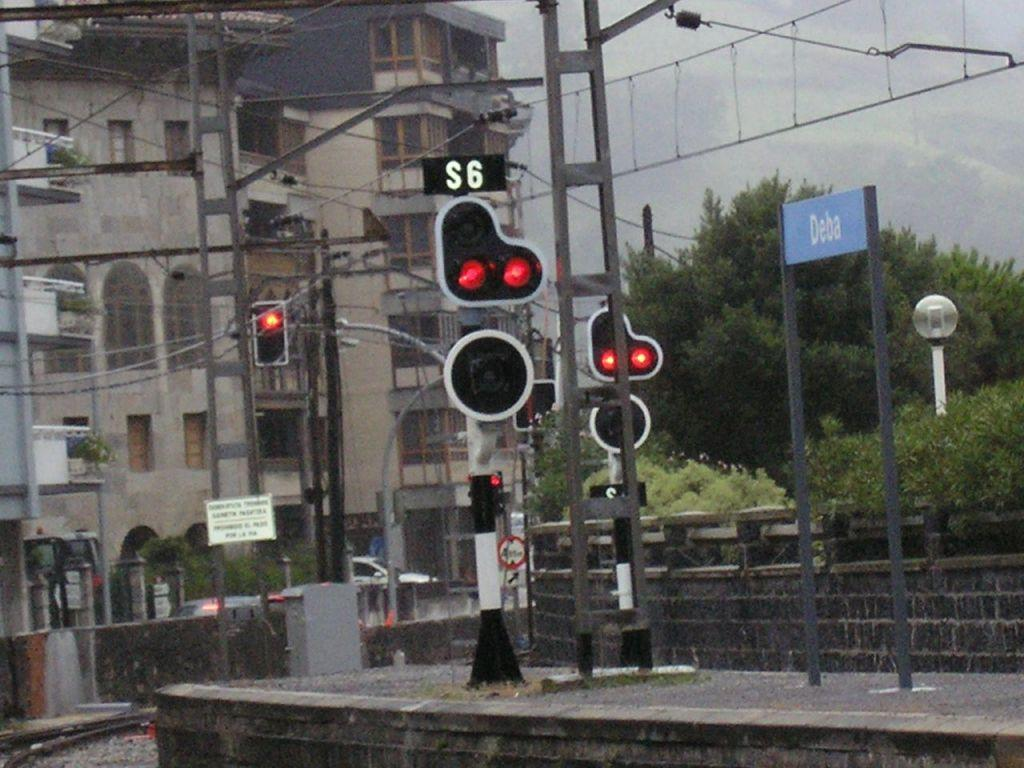<image>
Give a short and clear explanation of the subsequent image. the number 6 that is above a red light 